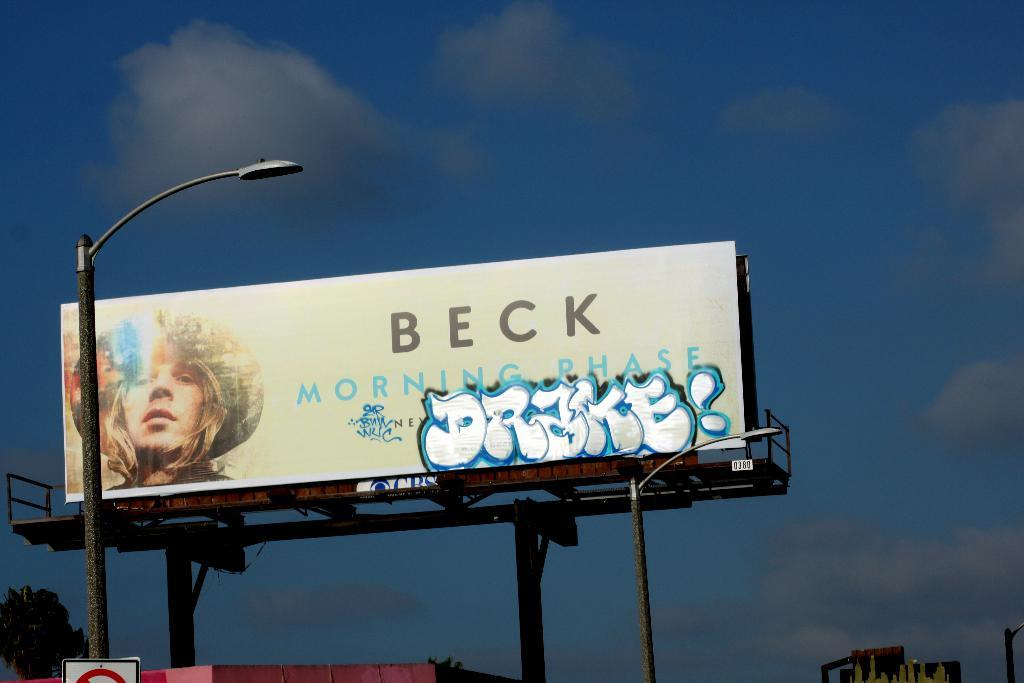<image>
Create a compact narrative representing the image presented. An outdoor billboard that has Beck at the top. 